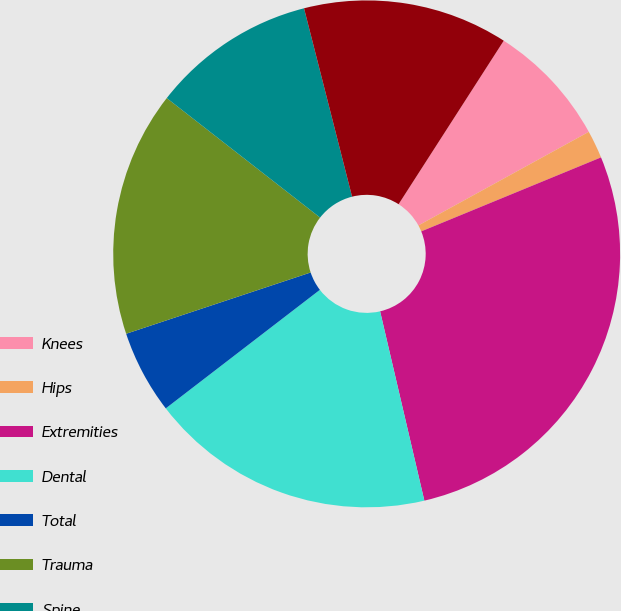Convert chart. <chart><loc_0><loc_0><loc_500><loc_500><pie_chart><fcel>Knees<fcel>Hips<fcel>Extremities<fcel>Dental<fcel>Total<fcel>Trauma<fcel>Spine<fcel>OSP and other<nl><fcel>7.91%<fcel>1.78%<fcel>27.56%<fcel>18.22%<fcel>5.33%<fcel>15.64%<fcel>10.49%<fcel>13.07%<nl></chart> 